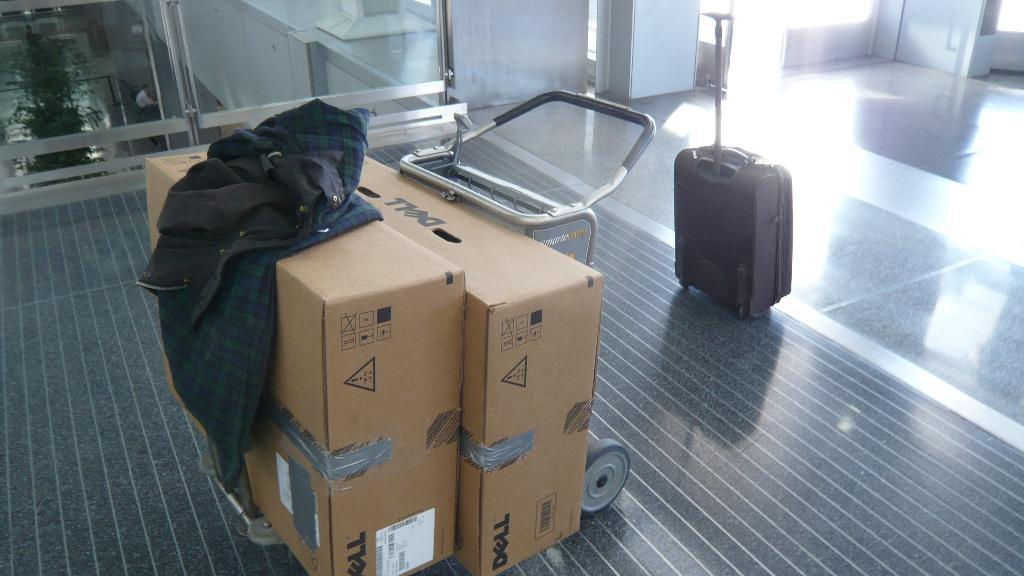What type of luggage is visible in the image? There is a travelling suitcase in the image. What other objects can be seen in the image? There are cardboard boxes in the image. Where is the fork located in the image? There is no fork present in the image. What type of spider web can be seen in the image? There is no spider web or garden present in the image. 